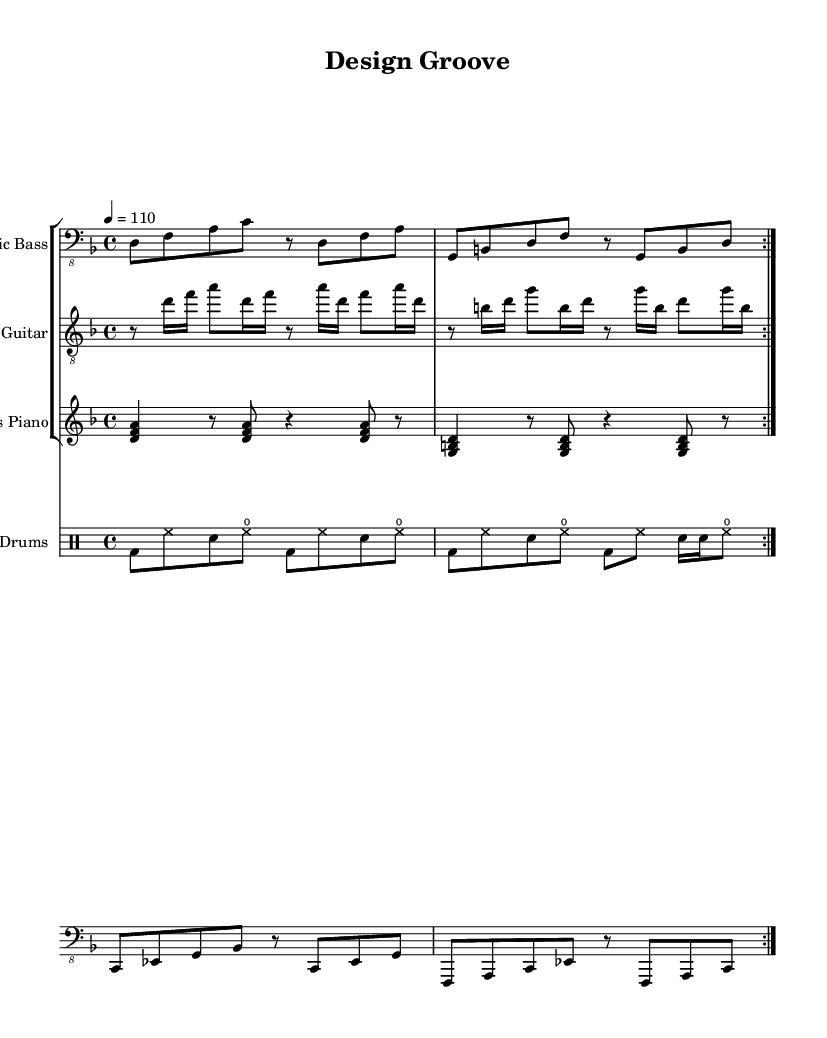What is the key signature of this music? The key signature is indicated by the symbol at the beginning of the staff. In this case, the presence of one flat indicates D minor.
Answer: D minor What is the time signature of this music? The time signature is indicated at the beginning of the piece, displayed as a fraction. Here, it shows 4 over 4, which means there are four beats in each measure, and the quarter note gets one beat.
Answer: 4/4 What is the tempo marking for this piece? The tempo is indicated above the staff with a metronome marking, which is given as 4 equals 110 beats per minute. This means to play at a moderately fast tempo.
Answer: 110 How many bars are repeated in the main sections? The sections of the score that indicate repeated passages are marked with "volta 2," which means there are two instances of playback per the repeated measures shown. Counting the separate bars reveals there are four bars that repeat in both electric bass and electric guitar parts.
Answer: 4 What type of drum pattern is used in the drums part? The drum part features a straight eight-note pattern, characterized by its consistent eighth note pulse throughout most of the measures, with accents on certain beats. This establishes a groove often found in funk music.
Answer: Straight eighths What is the primary instrument used for chords in this music? The primary instrument providing chords in this composition is the Rhodes piano, which is indicated by its staff and showcases block chords in the score. The block chords create a harmonic foundation typical of funk.
Answer: Rhodes piano How does this piece exhibit funk characteristics? The groove and syncopated rhythms found throughout the bass, guitar, and drums create a laid-back yet danceable feel, typical of funk music. This includes intricate bass lines and rhythmic guitar playing that emphasize the off-beats.
Answer: Syncopation 